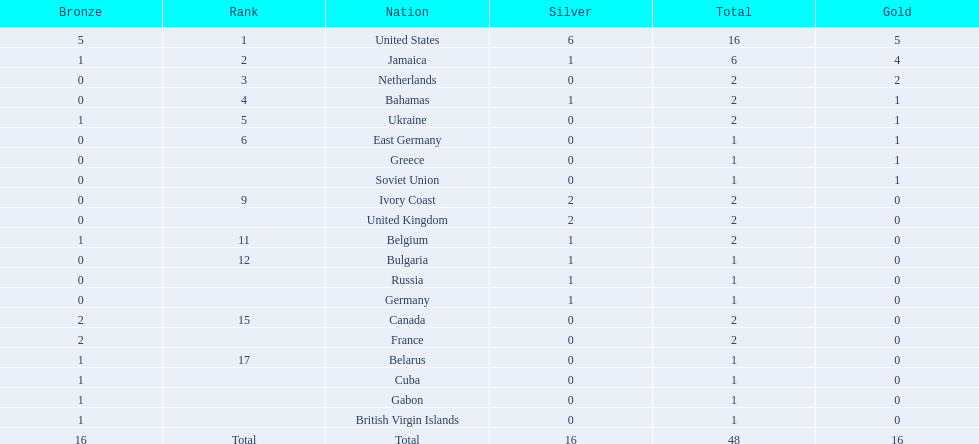After the united states, what country won the most gold medals. Jamaica. 